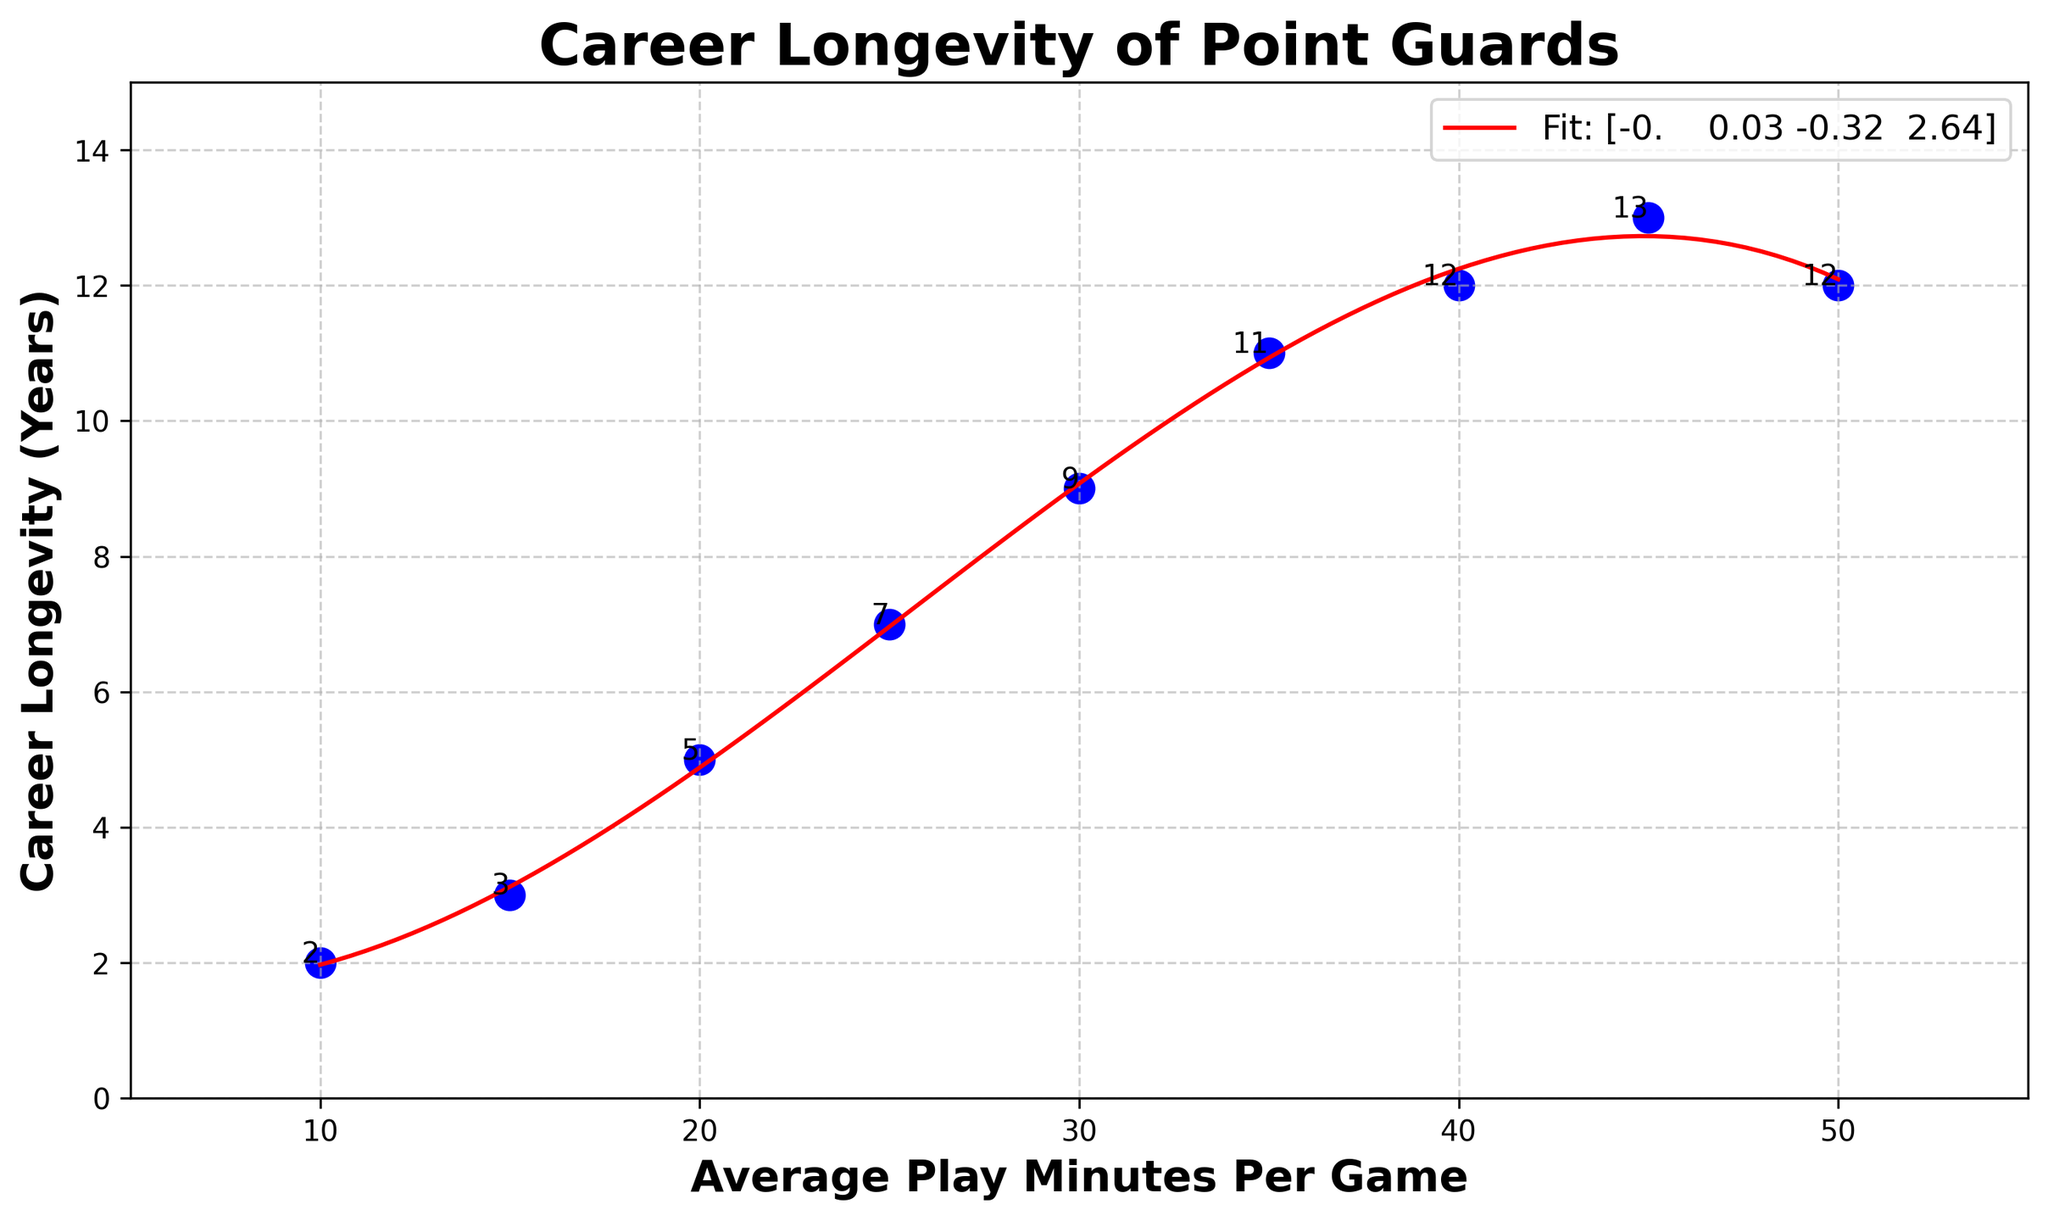What's the maximum career longevity of point guards observed in the data? The scatterplot shows the individual data points representing career longevity. The highest y-value among these points is 13 years.
Answer: 13 Between which two average play minutes per game does the career longevity start to decline, according to the plot's trend line? Referring to the trend line, career longevity peaks around 45 minutes per game and then starts to decline beyond that point.
Answer: 45 and 50 What's the average career longevity of point guards when their average play minutes per game is 25 or more? The data points where average play minutes are 25, 30, 35, 40, 45, and 50 correspond to career longevity of 7, 9, 11, 12, 13, and 12 years respectively. Summing these values (7+9+11+12+13+12=64) and dividing by 6 gives the average, which is 64/6 ≈ 10.67 years.
Answer: 10.67 Which point on the scatterplot represents the shortest career longevity and what is its respective play minutes per game? The shortest career longevity is 2 years, observed at 10 minutes per game as per the scatterplot annotation.
Answer: 10, 2 At what average play minutes per game does the trend line indicate the first increase in career longevity after an initial drop? Starting from 10 minutes per game, the trend line first increases significantly after 15 minutes per game, which marks the initial increase in career longevity.
Answer: 15 